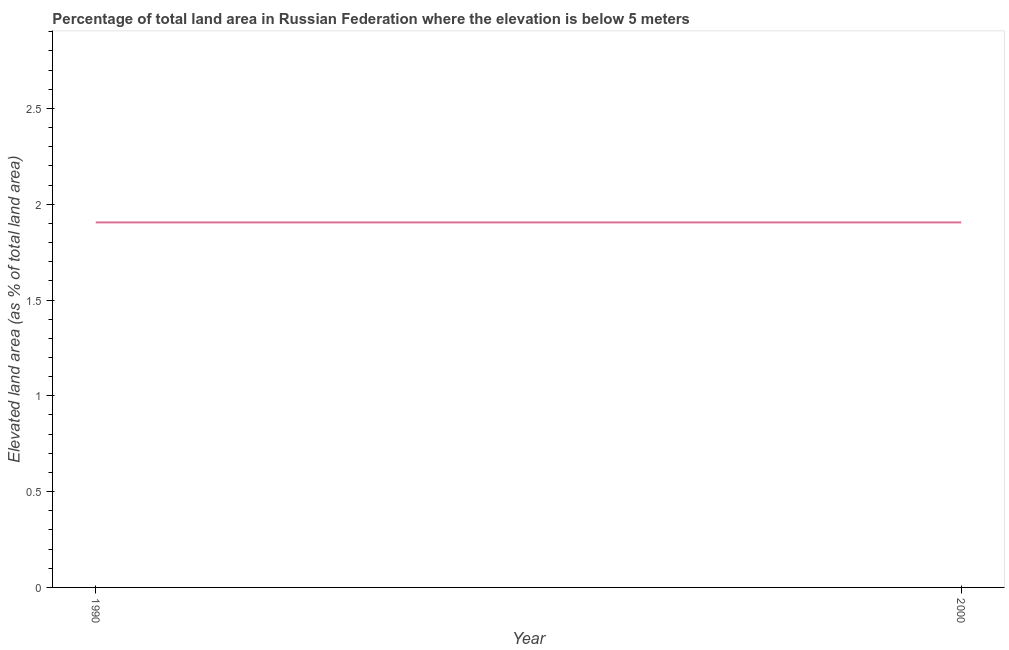What is the total elevated land area in 1990?
Make the answer very short. 1.91. Across all years, what is the maximum total elevated land area?
Provide a succinct answer. 1.91. Across all years, what is the minimum total elevated land area?
Make the answer very short. 1.91. In which year was the total elevated land area minimum?
Your answer should be very brief. 1990. What is the sum of the total elevated land area?
Make the answer very short. 3.81. What is the average total elevated land area per year?
Offer a terse response. 1.91. What is the median total elevated land area?
Offer a very short reply. 1.91. How many lines are there?
Keep it short and to the point. 1. How many years are there in the graph?
Ensure brevity in your answer.  2. What is the difference between two consecutive major ticks on the Y-axis?
Keep it short and to the point. 0.5. Does the graph contain any zero values?
Your answer should be compact. No. Does the graph contain grids?
Keep it short and to the point. No. What is the title of the graph?
Provide a short and direct response. Percentage of total land area in Russian Federation where the elevation is below 5 meters. What is the label or title of the Y-axis?
Offer a terse response. Elevated land area (as % of total land area). What is the Elevated land area (as % of total land area) of 1990?
Keep it short and to the point. 1.91. What is the Elevated land area (as % of total land area) in 2000?
Your response must be concise. 1.91. What is the difference between the Elevated land area (as % of total land area) in 1990 and 2000?
Ensure brevity in your answer.  0. 